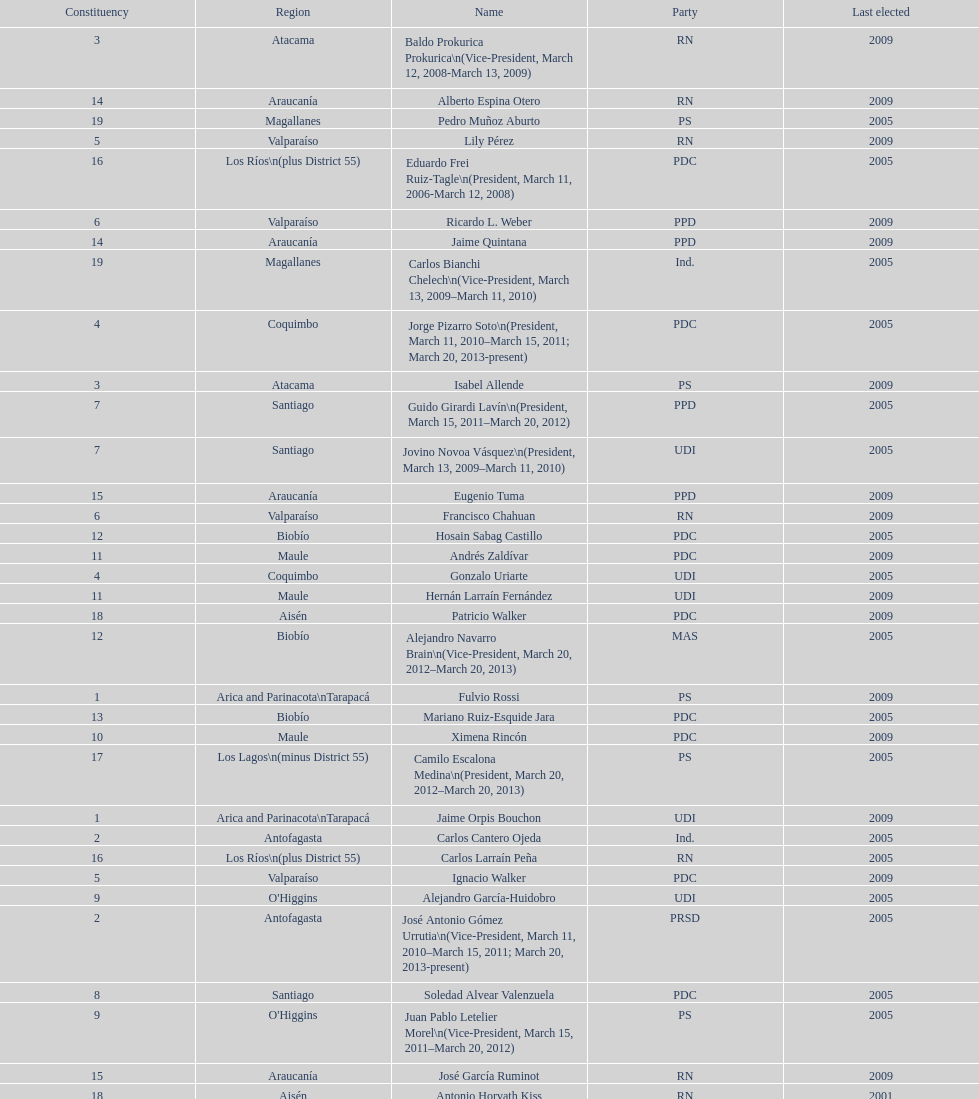How long was baldo prokurica prokurica vice-president? 1 year. 